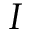<formula> <loc_0><loc_0><loc_500><loc_500>I</formula> 